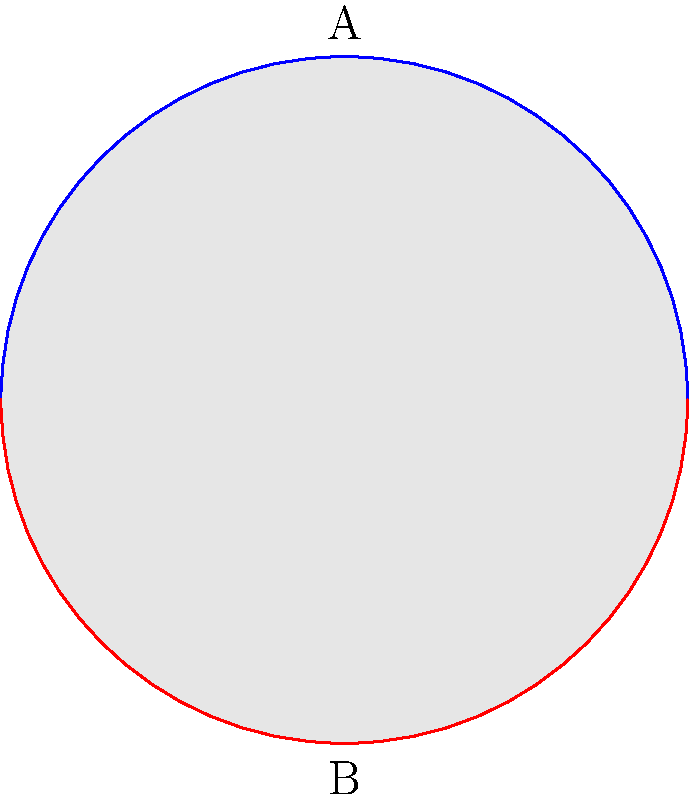Consider the topological space represented by the circle above, where the blue arc represents predominantly white neighborhoods and the red arc represents predominantly black neighborhoods in a segregated urban area during the Jim Crow era. What is the fundamental group of this space, and how does it relate to the social dynamics of racial segregation? To determine the fundamental group of this space and relate it to racial segregation, we follow these steps:

1) Observe the space: The space is a circle divided into two regions (blue and red arcs) representing segregated neighborhoods.

2) Identify the fundamental group: The fundamental group of a circle is isomorphic to the integers under addition, denoted as $\pi_1(S^1) \cong \mathbb{Z}$.

3) Interpret loops: Each loop around the circle can be thought of as a "journey" through the segregated city.

4) Homotopy classes: Different loops that can be continuously deformed into each other belong to the same homotopy class.

5) Generator of the group: A single counterclockwise loop around the circle generates the fundamental group.

6) Social interpretation: 
   - The generator represents a complete traversal of the segregated city.
   - The integer coefficient represents the number of times one completely traverses the city.
   - Positive integers represent counterclockwise traversals, negative integers represent clockwise traversals.

7) Barriers and continuity: The fundamental group being $\mathbb{Z}$ implies that despite segregation, the space remains connected. There's no topological barrier preventing movement between regions.

8) Social dynamics: This reflects that while segregation existed, it didn't create completely disconnected communities. There were still paths (however restricted) connecting different areas.

9) Persistence of structure: The non-trivial fundamental group ($\mathbb{Z}$ instead of the trivial group) suggests that the effects of segregation create a persistent structure in the urban landscape.
Answer: $\pi_1(S^1) \cong \mathbb{Z}$, reflecting connected but segregated communities. 